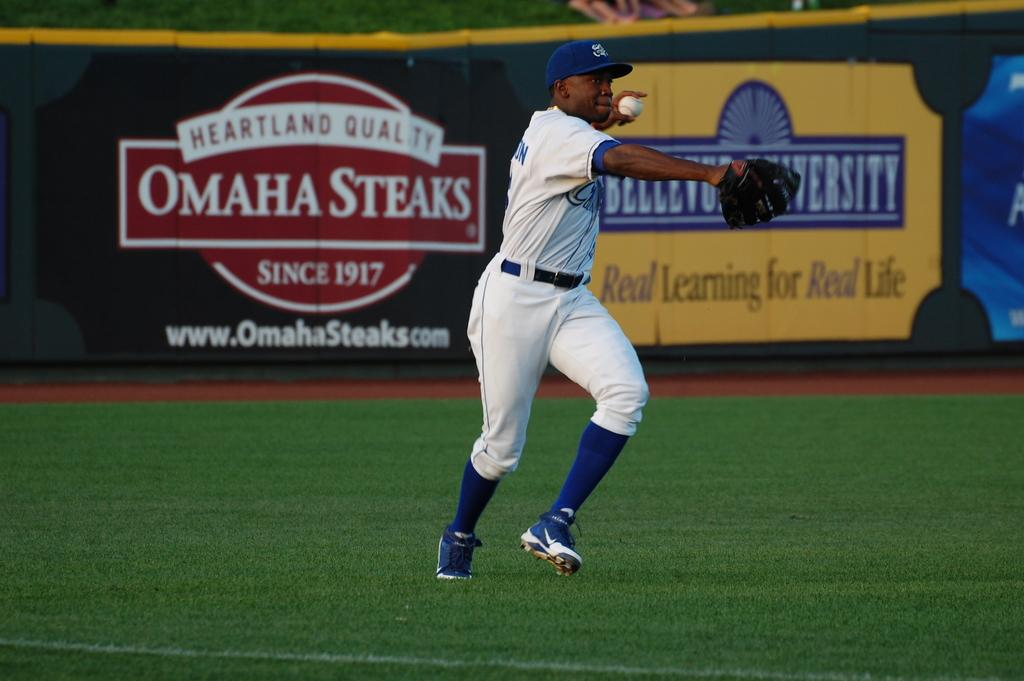<image>
Write a terse but informative summary of the picture. An ad for Omaha Steaks sits next to a yellow ad in the ballpark. 